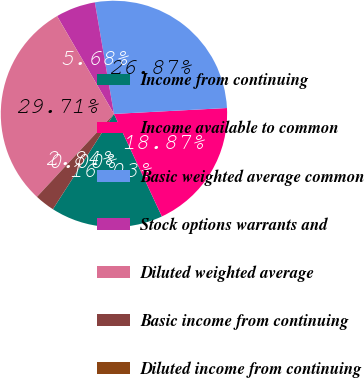<chart> <loc_0><loc_0><loc_500><loc_500><pie_chart><fcel>Income from continuing<fcel>Income available to common<fcel>Basic weighted average common<fcel>Stock options warrants and<fcel>Diluted weighted average<fcel>Basic income from continuing<fcel>Diluted income from continuing<nl><fcel>16.03%<fcel>18.87%<fcel>26.87%<fcel>5.68%<fcel>29.71%<fcel>2.84%<fcel>0.0%<nl></chart> 